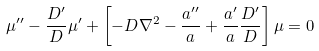<formula> <loc_0><loc_0><loc_500><loc_500>\mu ^ { \prime \prime } - \frac { D ^ { \prime } } { D } \mu ^ { \prime } + \left [ - D \nabla ^ { 2 } - \frac { a ^ { \prime \prime } } { a } + \frac { a ^ { \prime } } { a } \frac { D ^ { \prime } } { D } \right ] \mu = 0</formula> 